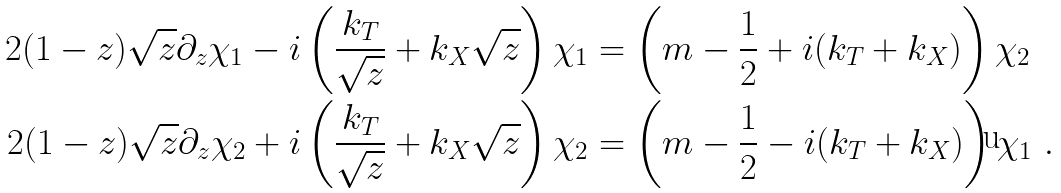<formula> <loc_0><loc_0><loc_500><loc_500>2 ( 1 - z ) \sqrt { z } \partial _ { z } \chi _ { 1 } - i \left ( \frac { k _ { T } } { \sqrt { z } } + k _ { X } \sqrt { z } \right ) \chi _ { 1 } & = \left ( m - \frac { 1 } { 2 } + i ( k _ { T } + k _ { X } ) \right ) \chi _ { 2 } \\ 2 ( 1 - z ) \sqrt { z } \partial _ { z } \chi _ { 2 } + i \left ( \frac { k _ { T } } { \sqrt { z } } + k _ { X } \sqrt { z } \right ) \chi _ { 2 } & = \left ( m - \frac { 1 } { 2 } - i ( k _ { T } + k _ { X } ) \right ) \chi _ { 1 } \ .</formula> 